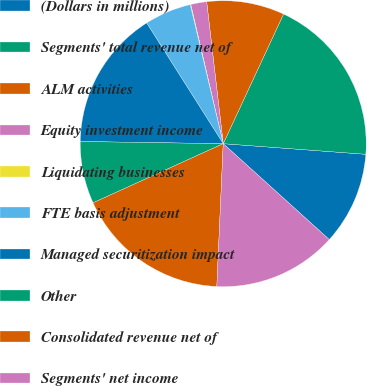Convert chart. <chart><loc_0><loc_0><loc_500><loc_500><pie_chart><fcel>(Dollars in millions)<fcel>Segments' total revenue net of<fcel>ALM activities<fcel>Equity investment income<fcel>Liquidating businesses<fcel>FTE basis adjustment<fcel>Managed securitization impact<fcel>Other<fcel>Consolidated revenue net of<fcel>Segments' net income<nl><fcel>10.52%<fcel>19.25%<fcel>8.78%<fcel>1.8%<fcel>0.06%<fcel>5.29%<fcel>15.76%<fcel>7.03%<fcel>17.5%<fcel>14.01%<nl></chart> 